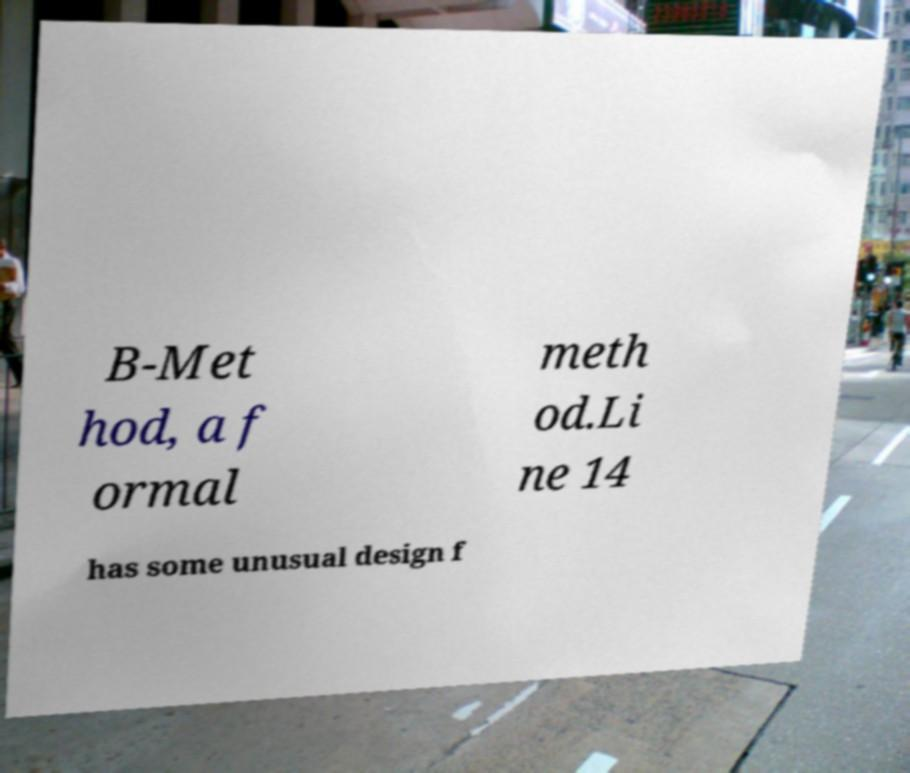Please read and relay the text visible in this image. What does it say? B-Met hod, a f ormal meth od.Li ne 14 has some unusual design f 